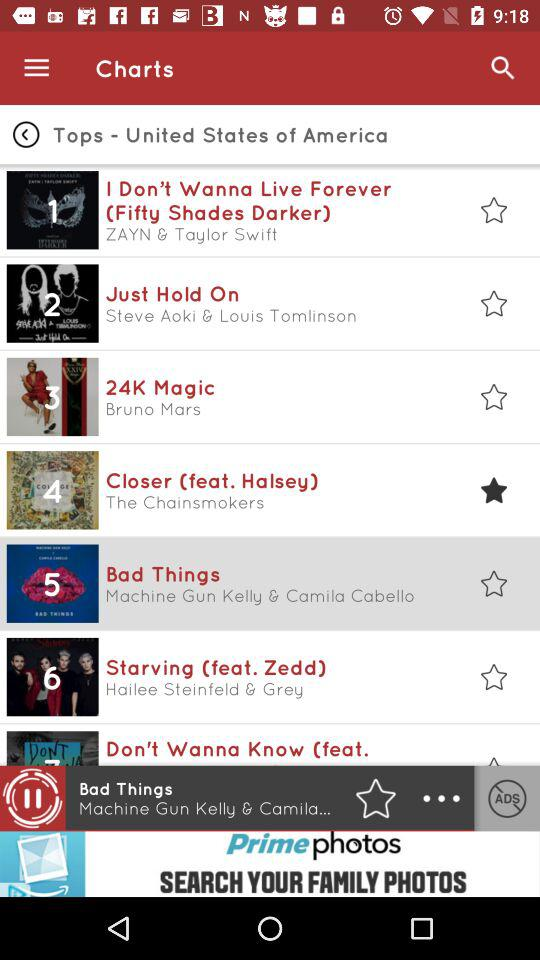Who is the singer of the song "24K Magic"? The singer is Bruno Mars. 